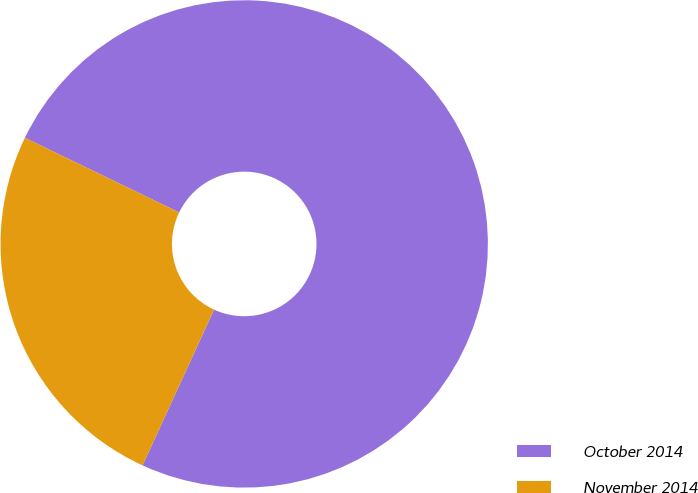<chart> <loc_0><loc_0><loc_500><loc_500><pie_chart><fcel>October 2014<fcel>November 2014<nl><fcel>74.68%<fcel>25.32%<nl></chart> 